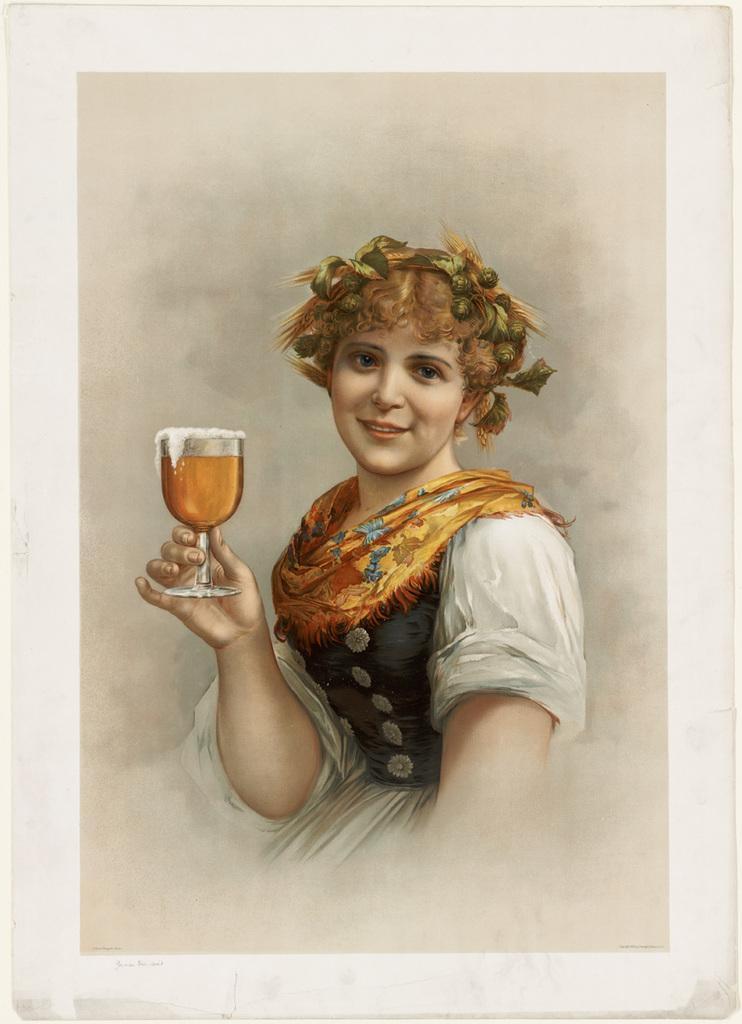Please provide a concise description of this image. This picture contains a photo frame in which woman wearing white and black dress is holding a glass containing liquid in her hand and she is smiling. 